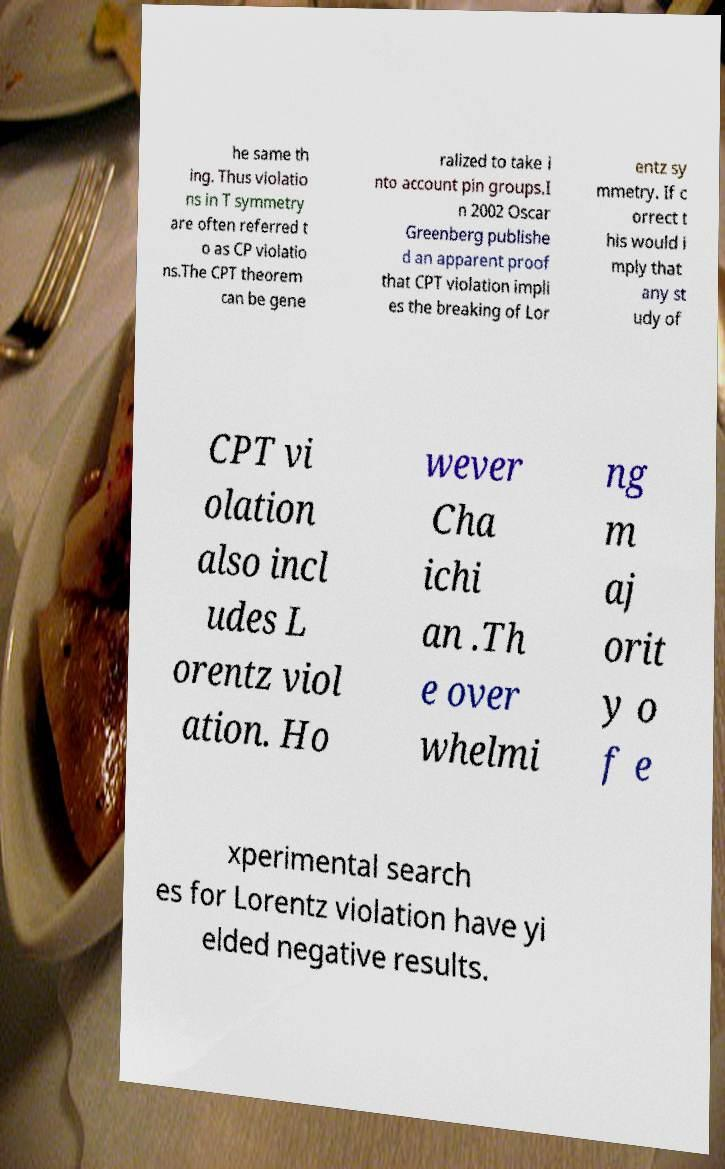Please identify and transcribe the text found in this image. he same th ing. Thus violatio ns in T symmetry are often referred t o as CP violatio ns.The CPT theorem can be gene ralized to take i nto account pin groups.I n 2002 Oscar Greenberg publishe d an apparent proof that CPT violation impli es the breaking of Lor entz sy mmetry. If c orrect t his would i mply that any st udy of CPT vi olation also incl udes L orentz viol ation. Ho wever Cha ichi an .Th e over whelmi ng m aj orit y o f e xperimental search es for Lorentz violation have yi elded negative results. 